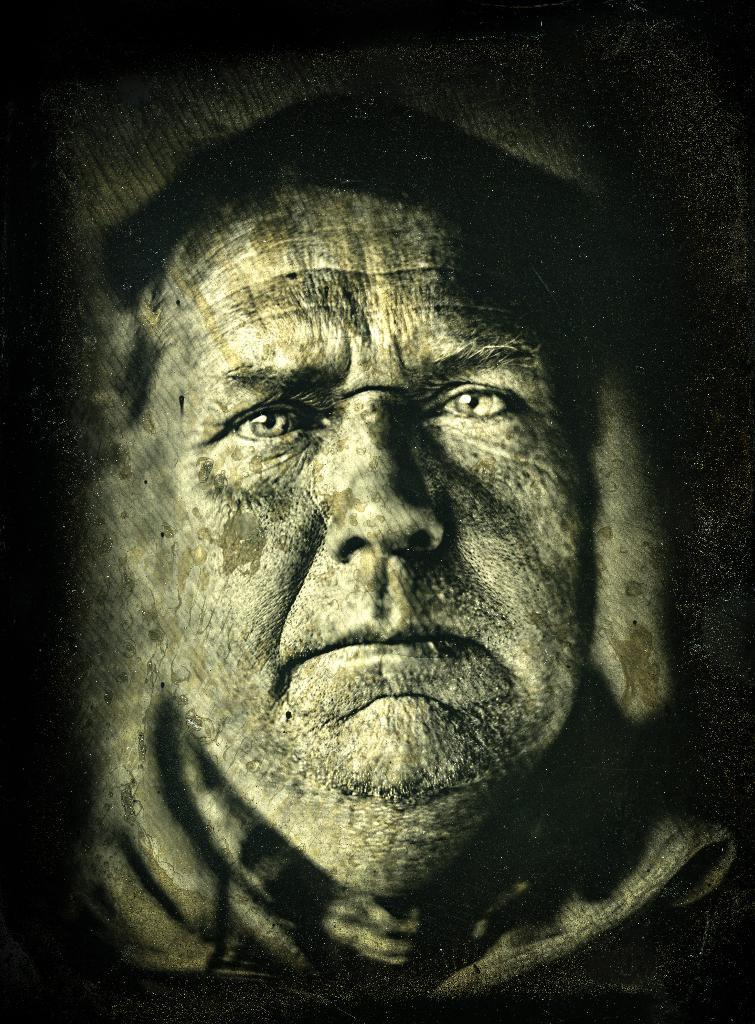What is depicted in the painting in the image? There is a painting of a man in the image. What color scheme is used in the image? The image is black and white in color. What type of book is the man reading in the painting? There is no book present in the painting; it only depicts a man. How many pigs can be seen in the painting? There are no pigs present in the painting; it only depicts a man. 